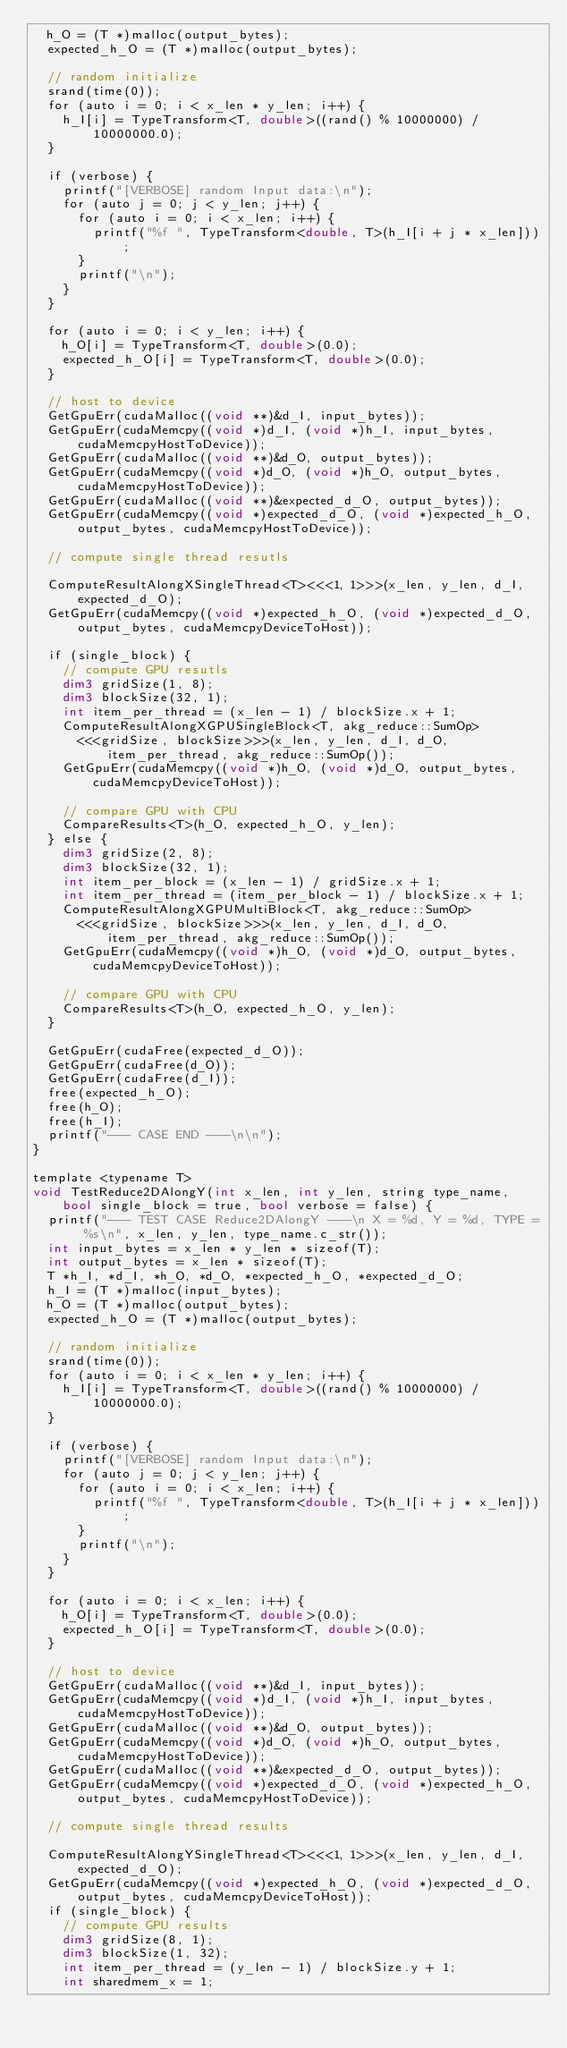Convert code to text. <code><loc_0><loc_0><loc_500><loc_500><_Cuda_>  h_O = (T *)malloc(output_bytes);
  expected_h_O = (T *)malloc(output_bytes);

  // random initialize
  srand(time(0));
  for (auto i = 0; i < x_len * y_len; i++) {
    h_I[i] = TypeTransform<T, double>((rand() % 10000000) / 10000000.0);
  }

  if (verbose) {
    printf("[VERBOSE] random Input data:\n");
    for (auto j = 0; j < y_len; j++) {
      for (auto i = 0; i < x_len; i++) {
        printf("%f ", TypeTransform<double, T>(h_I[i + j * x_len]));
      }
      printf("\n");
    }
  }

  for (auto i = 0; i < y_len; i++) {
    h_O[i] = TypeTransform<T, double>(0.0);
    expected_h_O[i] = TypeTransform<T, double>(0.0);
  }

  // host to device
  GetGpuErr(cudaMalloc((void **)&d_I, input_bytes));
  GetGpuErr(cudaMemcpy((void *)d_I, (void *)h_I, input_bytes, cudaMemcpyHostToDevice));
  GetGpuErr(cudaMalloc((void **)&d_O, output_bytes));
  GetGpuErr(cudaMemcpy((void *)d_O, (void *)h_O, output_bytes, cudaMemcpyHostToDevice));
  GetGpuErr(cudaMalloc((void **)&expected_d_O, output_bytes));
  GetGpuErr(cudaMemcpy((void *)expected_d_O, (void *)expected_h_O, output_bytes, cudaMemcpyHostToDevice));

  // compute single thread resutls

  ComputeResultAlongXSingleThread<T><<<1, 1>>>(x_len, y_len, d_I, expected_d_O);
  GetGpuErr(cudaMemcpy((void *)expected_h_O, (void *)expected_d_O, output_bytes, cudaMemcpyDeviceToHost));

  if (single_block) {
    // compute GPU resutls
    dim3 gridSize(1, 8);
    dim3 blockSize(32, 1);
    int item_per_thread = (x_len - 1) / blockSize.x + 1;
    ComputeResultAlongXGPUSingleBlock<T, akg_reduce::SumOp>
      <<<gridSize, blockSize>>>(x_len, y_len, d_I, d_O, item_per_thread, akg_reduce::SumOp());
    GetGpuErr(cudaMemcpy((void *)h_O, (void *)d_O, output_bytes, cudaMemcpyDeviceToHost));

    // compare GPU with CPU
    CompareResults<T>(h_O, expected_h_O, y_len);
  } else {
    dim3 gridSize(2, 8);
    dim3 blockSize(32, 1);
    int item_per_block = (x_len - 1) / gridSize.x + 1;
    int item_per_thread = (item_per_block - 1) / blockSize.x + 1;
    ComputeResultAlongXGPUMultiBlock<T, akg_reduce::SumOp>
      <<<gridSize, blockSize>>>(x_len, y_len, d_I, d_O, item_per_thread, akg_reduce::SumOp());
    GetGpuErr(cudaMemcpy((void *)h_O, (void *)d_O, output_bytes, cudaMemcpyDeviceToHost));

    // compare GPU with CPU
    CompareResults<T>(h_O, expected_h_O, y_len);
  }

  GetGpuErr(cudaFree(expected_d_O));
  GetGpuErr(cudaFree(d_O));
  GetGpuErr(cudaFree(d_I));
  free(expected_h_O);
  free(h_O);
  free(h_I);
  printf("--- CASE END ---\n\n");
}

template <typename T>
void TestReduce2DAlongY(int x_len, int y_len, string type_name, bool single_block = true, bool verbose = false) {
  printf("--- TEST CASE Reduce2DAlongY ---\n X = %d, Y = %d, TYPE = %s\n", x_len, y_len, type_name.c_str());
  int input_bytes = x_len * y_len * sizeof(T);
  int output_bytes = x_len * sizeof(T);
  T *h_I, *d_I, *h_O, *d_O, *expected_h_O, *expected_d_O;
  h_I = (T *)malloc(input_bytes);
  h_O = (T *)malloc(output_bytes);
  expected_h_O = (T *)malloc(output_bytes);

  // random initialize
  srand(time(0));
  for (auto i = 0; i < x_len * y_len; i++) {
    h_I[i] = TypeTransform<T, double>((rand() % 10000000) / 10000000.0);
  }

  if (verbose) {
    printf("[VERBOSE] random Input data:\n");
    for (auto j = 0; j < y_len; j++) {
      for (auto i = 0; i < x_len; i++) {
        printf("%f ", TypeTransform<double, T>(h_I[i + j * x_len]));
      }
      printf("\n");
    }
  }

  for (auto i = 0; i < x_len; i++) {
    h_O[i] = TypeTransform<T, double>(0.0);
    expected_h_O[i] = TypeTransform<T, double>(0.0);
  }

  // host to device
  GetGpuErr(cudaMalloc((void **)&d_I, input_bytes));
  GetGpuErr(cudaMemcpy((void *)d_I, (void *)h_I, input_bytes, cudaMemcpyHostToDevice));
  GetGpuErr(cudaMalloc((void **)&d_O, output_bytes));
  GetGpuErr(cudaMemcpy((void *)d_O, (void *)h_O, output_bytes, cudaMemcpyHostToDevice));
  GetGpuErr(cudaMalloc((void **)&expected_d_O, output_bytes));
  GetGpuErr(cudaMemcpy((void *)expected_d_O, (void *)expected_h_O, output_bytes, cudaMemcpyHostToDevice));

  // compute single thread results

  ComputeResultAlongYSingleThread<T><<<1, 1>>>(x_len, y_len, d_I, expected_d_O);
  GetGpuErr(cudaMemcpy((void *)expected_h_O, (void *)expected_d_O, output_bytes, cudaMemcpyDeviceToHost));
  if (single_block) {
    // compute GPU results
    dim3 gridSize(8, 1);
    dim3 blockSize(1, 32);
    int item_per_thread = (y_len - 1) / blockSize.y + 1;
    int sharedmem_x = 1;</code> 